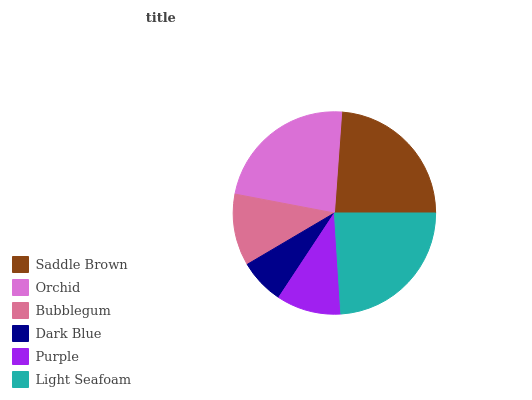Is Dark Blue the minimum?
Answer yes or no. Yes. Is Light Seafoam the maximum?
Answer yes or no. Yes. Is Orchid the minimum?
Answer yes or no. No. Is Orchid the maximum?
Answer yes or no. No. Is Saddle Brown greater than Orchid?
Answer yes or no. Yes. Is Orchid less than Saddle Brown?
Answer yes or no. Yes. Is Orchid greater than Saddle Brown?
Answer yes or no. No. Is Saddle Brown less than Orchid?
Answer yes or no. No. Is Orchid the high median?
Answer yes or no. Yes. Is Bubblegum the low median?
Answer yes or no. Yes. Is Light Seafoam the high median?
Answer yes or no. No. Is Saddle Brown the low median?
Answer yes or no. No. 